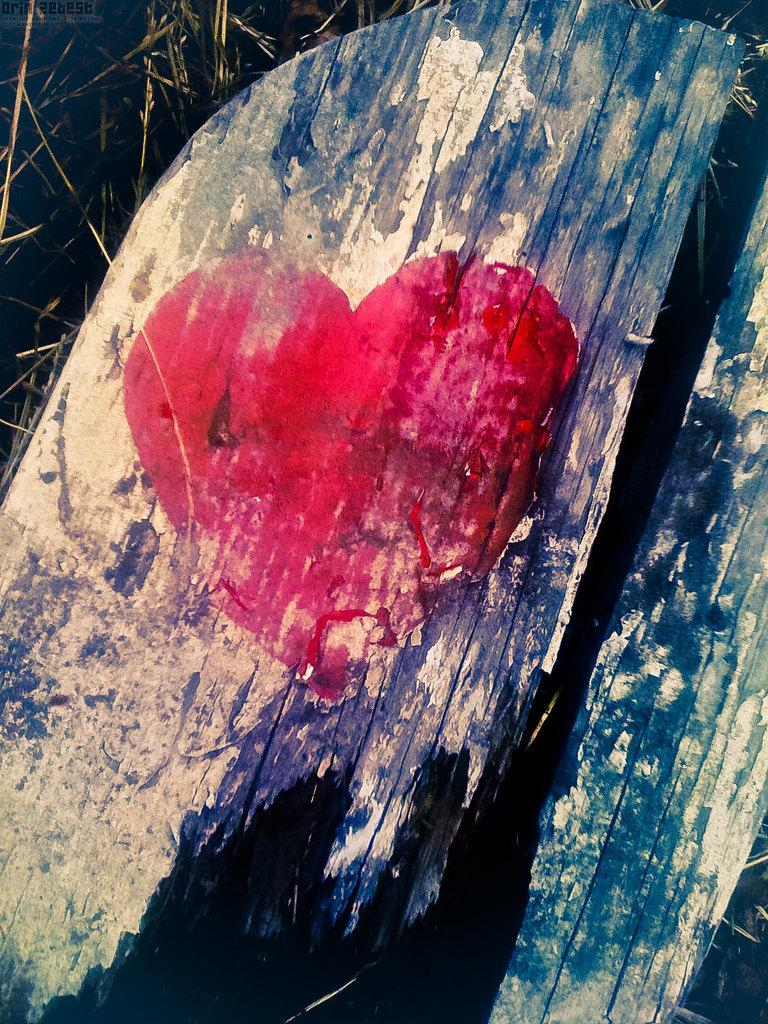What shape and color is the object on the wooden surface in the image? There is a red color heart shape on a wooden surface in the image. What can be seen in the background of the image? There are grasses in the background of the image. What type of silver material is present in the image? There is no silver material present in the image. Where is the town located in the image? There is no town present in the image; it only features a red heart shape on a wooden surface and grasses in the background. 